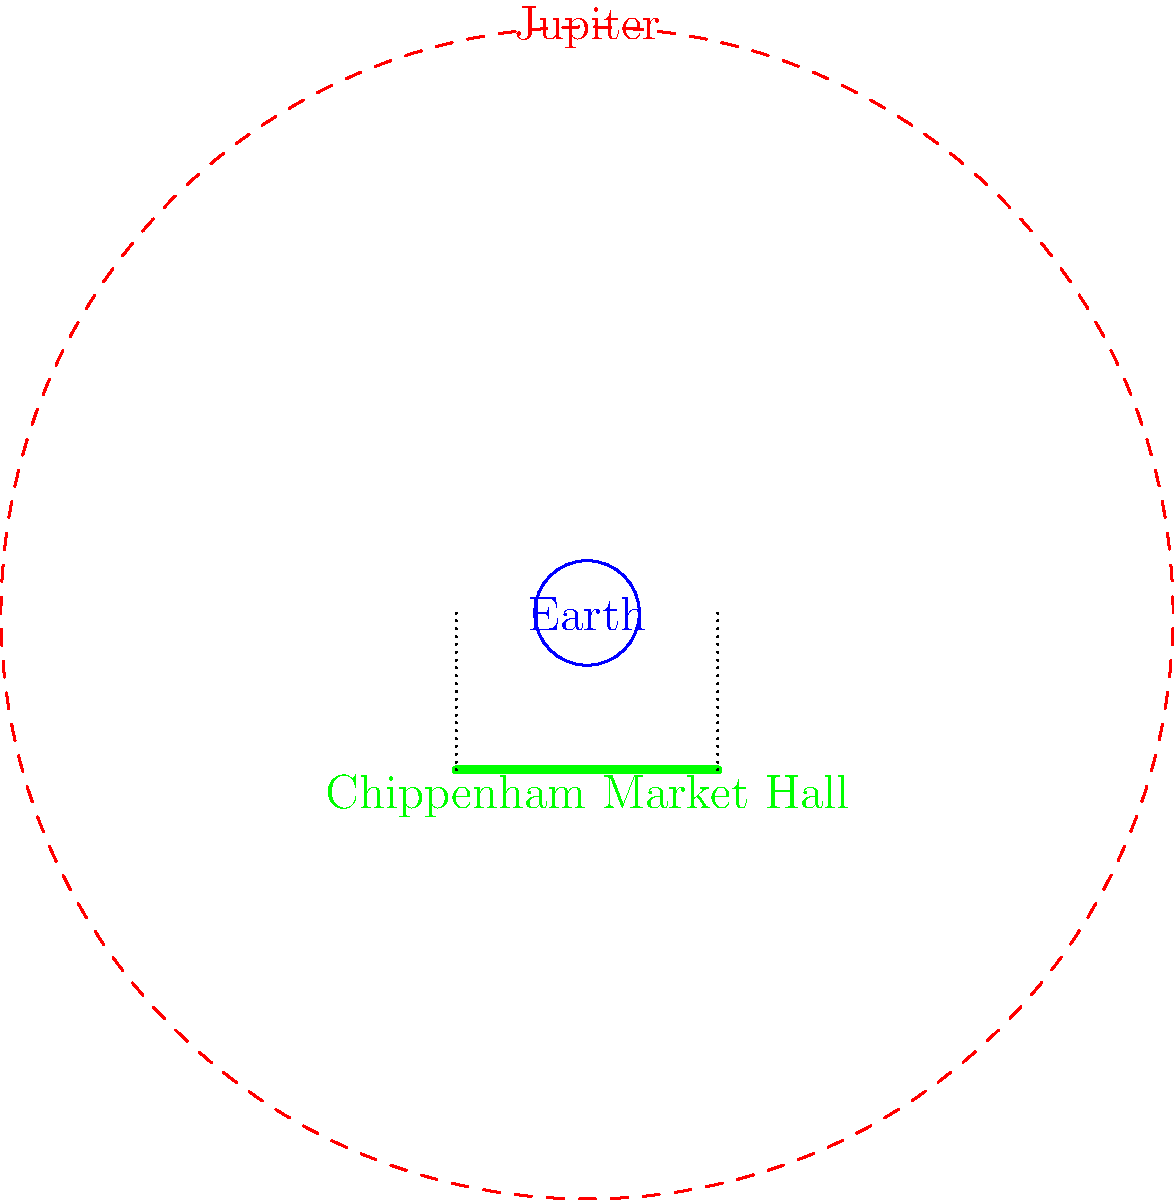If Earth were scaled down to the size of a tennis ball (about 6.7 cm in diameter) in Chippenham's Market Place, how would Jupiter's size compare to the width of the historic Market Hall? To answer this question, let's follow these steps:

1. Establish the relative sizes:
   - Earth's diameter: 12,742 km
   - Jupiter's diameter: 139,820 km
   - Chippenham Market Hall width: approximately 25 meters (estimated)

2. Calculate the scale factor:
   - Tennis ball diameter: 6.7 cm
   - Scale factor = 6.7 cm / 12,742 km = 5.26 × 10^-9

3. Scale Jupiter and the Market Hall:
   - Scaled Jupiter diameter: 139,820 km × 5.26 × 10^-9 = 73.5 cm
   - Scaled Market Hall width: 25 m × 5.26 × 10^-9 = 0.13 cm

4. Compare the sizes:
   - Jupiter's scaled diameter (73.5 cm) is about 565 times larger than the scaled Market Hall width (0.13 cm)

5. Visualize the comparison:
   - If Earth were a tennis ball in the Market Place, Jupiter would be about the size of a small car (73.5 cm or about 2.4 feet in diameter)
   - The Market Hall, in comparison, would be barely visible, only about 1.3 mm wide

Therefore, at this scale, Jupiter would appear enormously larger than the Market Hall, dwarfing not only the building but most of Chippenham's town center.
Answer: Jupiter would be about 565 times wider than the Market Hall. 